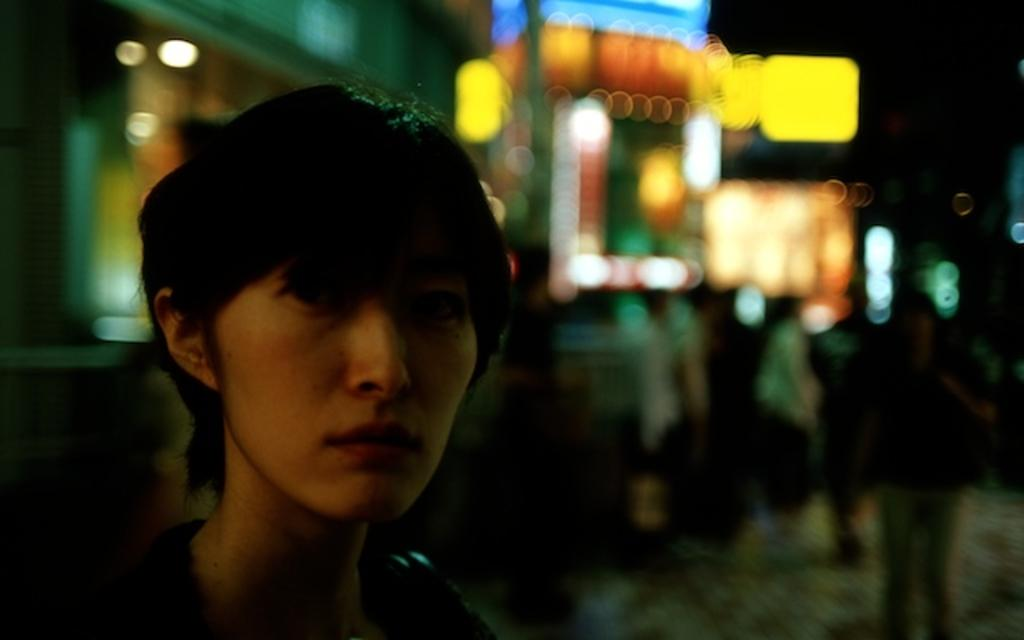Who is present in the image? There is a woman in the image. What is the woman doing in the image? The woman is staring. What type of feather can be seen in the woman's hair in the image? There is no feather present in the woman's hair or in the image. 